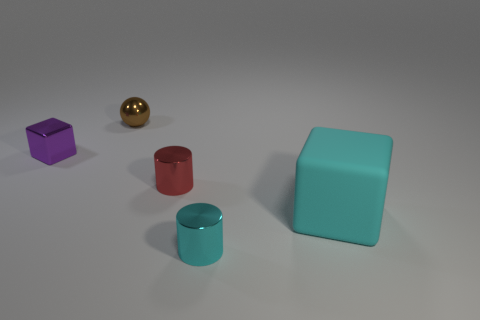Are there any brown spheres that have the same size as the purple metallic cube?
Your answer should be very brief. Yes. What is the material of the brown thing that is the same size as the red cylinder?
Make the answer very short. Metal. What number of objects are either shiny objects to the right of the tiny purple shiny object or tiny cylinders behind the rubber thing?
Your answer should be compact. 3. Is there a tiny red shiny object that has the same shape as the brown thing?
Offer a terse response. No. There is a tiny cylinder that is the same color as the large rubber block; what is its material?
Give a very brief answer. Metal. What number of metal things are cyan things or large cubes?
Make the answer very short. 1. The small cyan metal thing has what shape?
Provide a short and direct response. Cylinder. What number of other brown things have the same material as the big object?
Provide a succinct answer. 0. What is the color of the other small cylinder that is the same material as the red cylinder?
Provide a succinct answer. Cyan. There is a cube that is on the right side of the brown ball; is its size the same as the small purple metal cube?
Offer a terse response. No. 